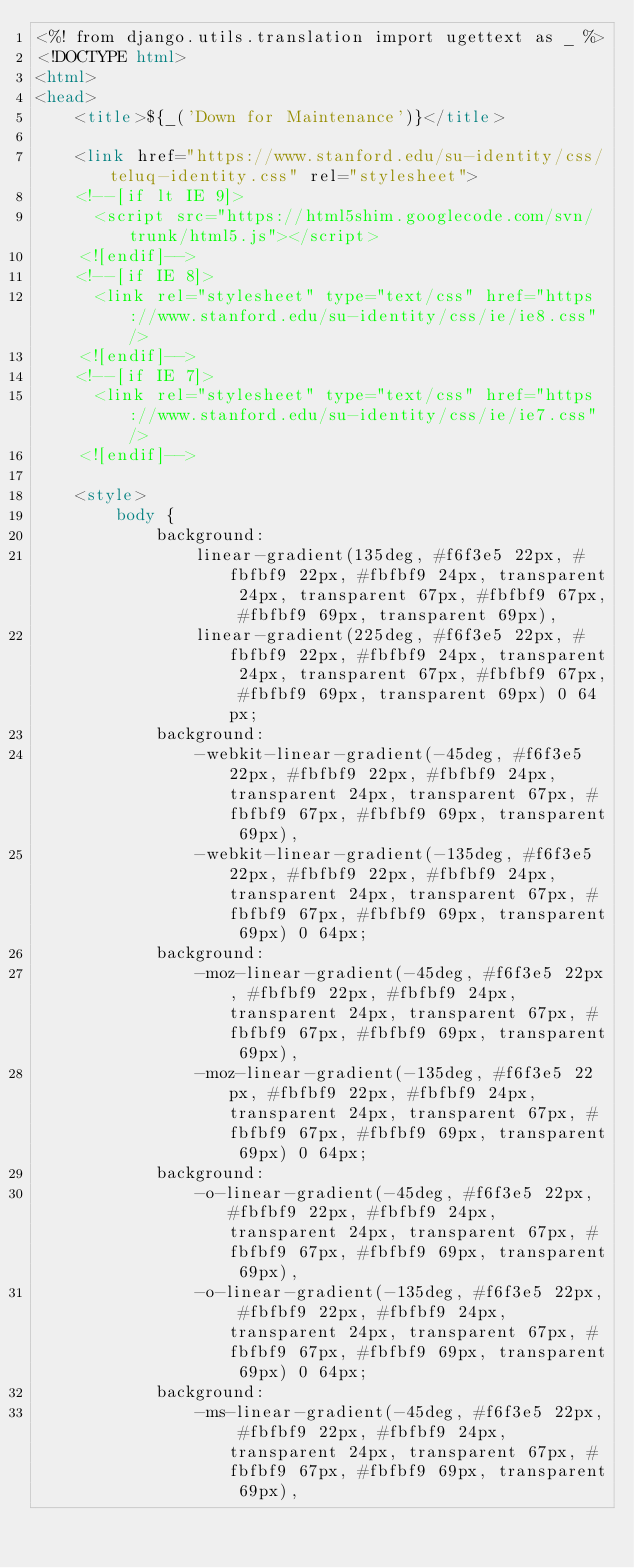Convert code to text. <code><loc_0><loc_0><loc_500><loc_500><_HTML_><%! from django.utils.translation import ugettext as _ %>
<!DOCTYPE html>
<html>
<head>
    <title>${_('Down for Maintenance')}</title>
  
    <link href="https://www.stanford.edu/su-identity/css/teluq-identity.css" rel="stylesheet">
    <!--[if lt IE 9]>
      <script src="https://html5shim.googlecode.com/svn/trunk/html5.js"></script>
    <![endif]-->
    <!--[if IE 8]>
      <link rel="stylesheet" type="text/css" href="https://www.stanford.edu/su-identity/css/ie/ie8.css" />
    <![endif]-->
    <!--[if IE 7]>
      <link rel="stylesheet" type="text/css" href="https://www.stanford.edu/su-identity/css/ie/ie7.css" />
    <![endif]-->
    
    <style>
        body {
            background:
                linear-gradient(135deg, #f6f3e5 22px, #fbfbf9 22px, #fbfbf9 24px, transparent 24px, transparent 67px, #fbfbf9 67px, #fbfbf9 69px, transparent 69px),
                linear-gradient(225deg, #f6f3e5 22px, #fbfbf9 22px, #fbfbf9 24px, transparent 24px, transparent 67px, #fbfbf9 67px, #fbfbf9 69px, transparent 69px) 0 64px;
            background:
                -webkit-linear-gradient(-45deg, #f6f3e5 22px, #fbfbf9 22px, #fbfbf9 24px, transparent 24px, transparent 67px, #fbfbf9 67px, #fbfbf9 69px, transparent 69px),
                -webkit-linear-gradient(-135deg, #f6f3e5 22px, #fbfbf9 22px, #fbfbf9 24px, transparent 24px, transparent 67px, #fbfbf9 67px, #fbfbf9 69px, transparent 69px) 0 64px;
            background:
                -moz-linear-gradient(-45deg, #f6f3e5 22px, #fbfbf9 22px, #fbfbf9 24px, transparent 24px, transparent 67px, #fbfbf9 67px, #fbfbf9 69px, transparent 69px),
                -moz-linear-gradient(-135deg, #f6f3e5 22px, #fbfbf9 22px, #fbfbf9 24px, transparent 24px, transparent 67px, #fbfbf9 67px, #fbfbf9 69px, transparent 69px) 0 64px;
            background:
                -o-linear-gradient(-45deg, #f6f3e5 22px, #fbfbf9 22px, #fbfbf9 24px, transparent 24px, transparent 67px, #fbfbf9 67px, #fbfbf9 69px, transparent 69px),
                -o-linear-gradient(-135deg, #f6f3e5 22px, #fbfbf9 22px, #fbfbf9 24px, transparent 24px, transparent 67px, #fbfbf9 67px, #fbfbf9 69px, transparent 69px) 0 64px;
            background:
                -ms-linear-gradient(-45deg, #f6f3e5 22px, #fbfbf9 22px, #fbfbf9 24px, transparent 24px, transparent 67px, #fbfbf9 67px, #fbfbf9 69px, transparent 69px),</code> 